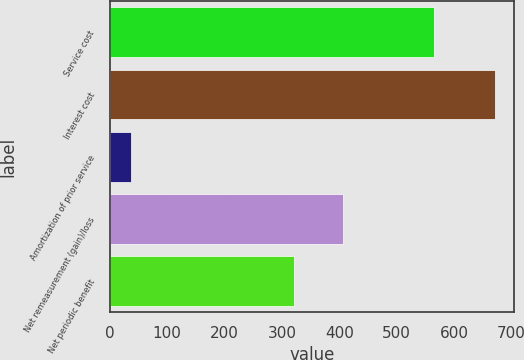<chart> <loc_0><loc_0><loc_500><loc_500><bar_chart><fcel>Service cost<fcel>Interest cost<fcel>Amortization of prior service<fcel>Net remeasurement (gain)/loss<fcel>Net periodic benefit<nl><fcel>566<fcel>671<fcel>37<fcel>407<fcel>321<nl></chart> 